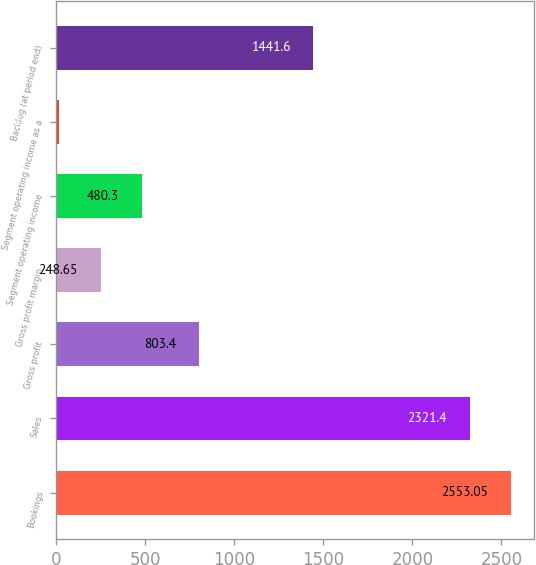Convert chart to OTSL. <chart><loc_0><loc_0><loc_500><loc_500><bar_chart><fcel>Bookings<fcel>Sales<fcel>Gross profit<fcel>Gross profit margin<fcel>Segment operating income<fcel>Segment operating income as a<fcel>Backlog (at period end)<nl><fcel>2553.05<fcel>2321.4<fcel>803.4<fcel>248.65<fcel>480.3<fcel>17<fcel>1441.6<nl></chart> 